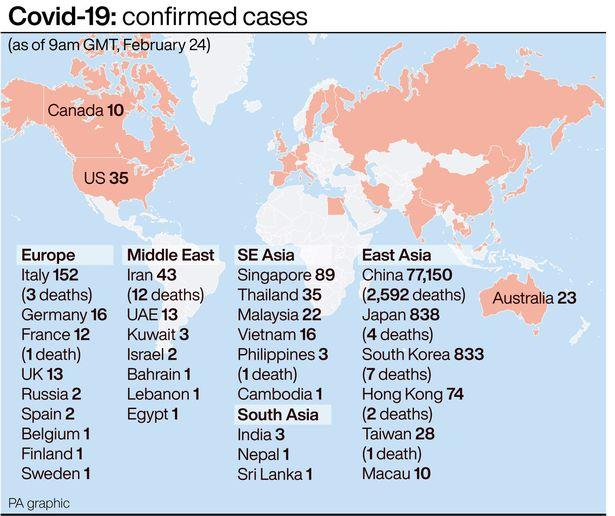List a handful of essential elements in this visual. There have been 152 confirmed cases of a disease in a European country, and 3 deaths have been reported. As of February 24, a total of 2,592 reported deaths had occurred in China. In South Korea, seven deaths were reported. As of February 24, it was reported that there were 3 deaths in Italy. Iran has the highest number of confirmed cases of COVID-19 in the Middle East. 